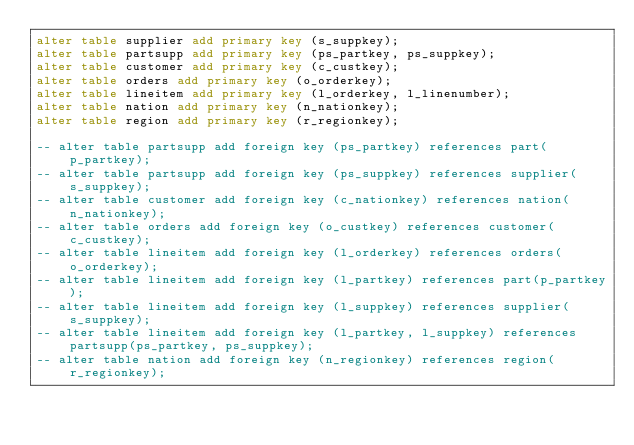Convert code to text. <code><loc_0><loc_0><loc_500><loc_500><_SQL_>alter table supplier add primary key (s_suppkey);
alter table partsupp add primary key (ps_partkey, ps_suppkey);
alter table customer add primary key (c_custkey);
alter table orders add primary key (o_orderkey);
alter table lineitem add primary key (l_orderkey, l_linenumber);
alter table nation add primary key (n_nationkey);
alter table region add primary key (r_regionkey);

-- alter table partsupp add foreign key (ps_partkey) references part(p_partkey);
-- alter table partsupp add foreign key (ps_suppkey) references supplier(s_suppkey);
-- alter table customer add foreign key (c_nationkey) references nation(n_nationkey);
-- alter table orders add foreign key (o_custkey) references customer(c_custkey);
-- alter table lineitem add foreign key (l_orderkey) references orders(o_orderkey);
-- alter table lineitem add foreign key (l_partkey) references part(p_partkey);
-- alter table lineitem add foreign key (l_suppkey) references supplier(s_suppkey);
-- alter table lineitem add foreign key (l_partkey, l_suppkey) references partsupp(ps_partkey, ps_suppkey);
-- alter table nation add foreign key (n_regionkey) references region(r_regionkey);
</code> 